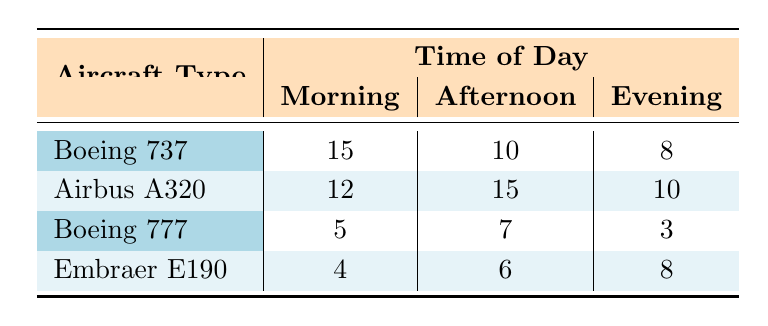What is the incident count for the Boeing 737 in the morning? According to the table, the incident count for the Boeing 737 in the morning is directly listed under the "Morning" column for that aircraft. It states 15 incidents.
Answer: 15 Which aircraft type has the highest incident count in the afternoon? From the table, looking at the "Afternoon" column, the Airbus A320 has the highest incident count listed as 15, compared to other aircraft.
Answer: Airbus A320 What is the total incident count for the Boeing 777 throughout all times of day? To find the total incident count for the Boeing 777, I need to add the incidents from all three time slots: 5 (Morning) + 7 (Afternoon) + 3 (Evening) = 15 incidents.
Answer: 15 Is the incident count for the Embraer E190 higher in the evening compared to the morning? In the table, the incident count for the Embraer E190 in the evening is 8, while in the morning it is 4. Since 8 is greater than 4, the statement is true.
Answer: Yes What is the average incident count for Airbus A320 across all times of day? The incident counts for the Airbus A320 are 12 (Morning), 15 (Afternoon), and 10 (Evening). To calculate the average, add these numbers: 12 + 15 + 10 = 37, then divide by 3 (the number of time periods): 37/3 = 12.33.
Answer: 12.33 Which aircraft had the fewest incidents in the evening? Looking at the "Evening" column in the table, the Boeing 777 has the lowest incident count at 3 compared to other aircraft types.
Answer: Boeing 777 What is the difference in incident counts between the morning and afternoon for Boeing 737? The Boeing 737 has 15 incidents in the morning and 10 in the afternoon. The difference can be calculated by subtracting: 15 - 10 = 5.
Answer: 5 Is the total count of incidents during the morning (all aircraft) greater than or equal to the total during the evening? In the morning, the total incidents are 15 (Boeing 737) + 12 (Airbus A320) + 5 (Boeing 777) + 4 (Embraer E190) = 36. In the evening, the total count is 8 (Boeing 737) + 10 (Airbus A320) + 3 (Boeing 777) + 8 (Embraer E190) = 29. Since 36 is greater than 29, the statement is true.
Answer: Yes What is the incident count for all aircraft types combined in the afternoon? The counts for the afternoon are 10 (Boeing 737) + 15 (Airbus A320) + 7 (Boeing 777) + 6 (Embraer E190), which totals up to 38 incidents.
Answer: 38 